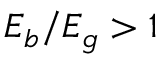<formula> <loc_0><loc_0><loc_500><loc_500>E _ { b } / E _ { g } > 1</formula> 